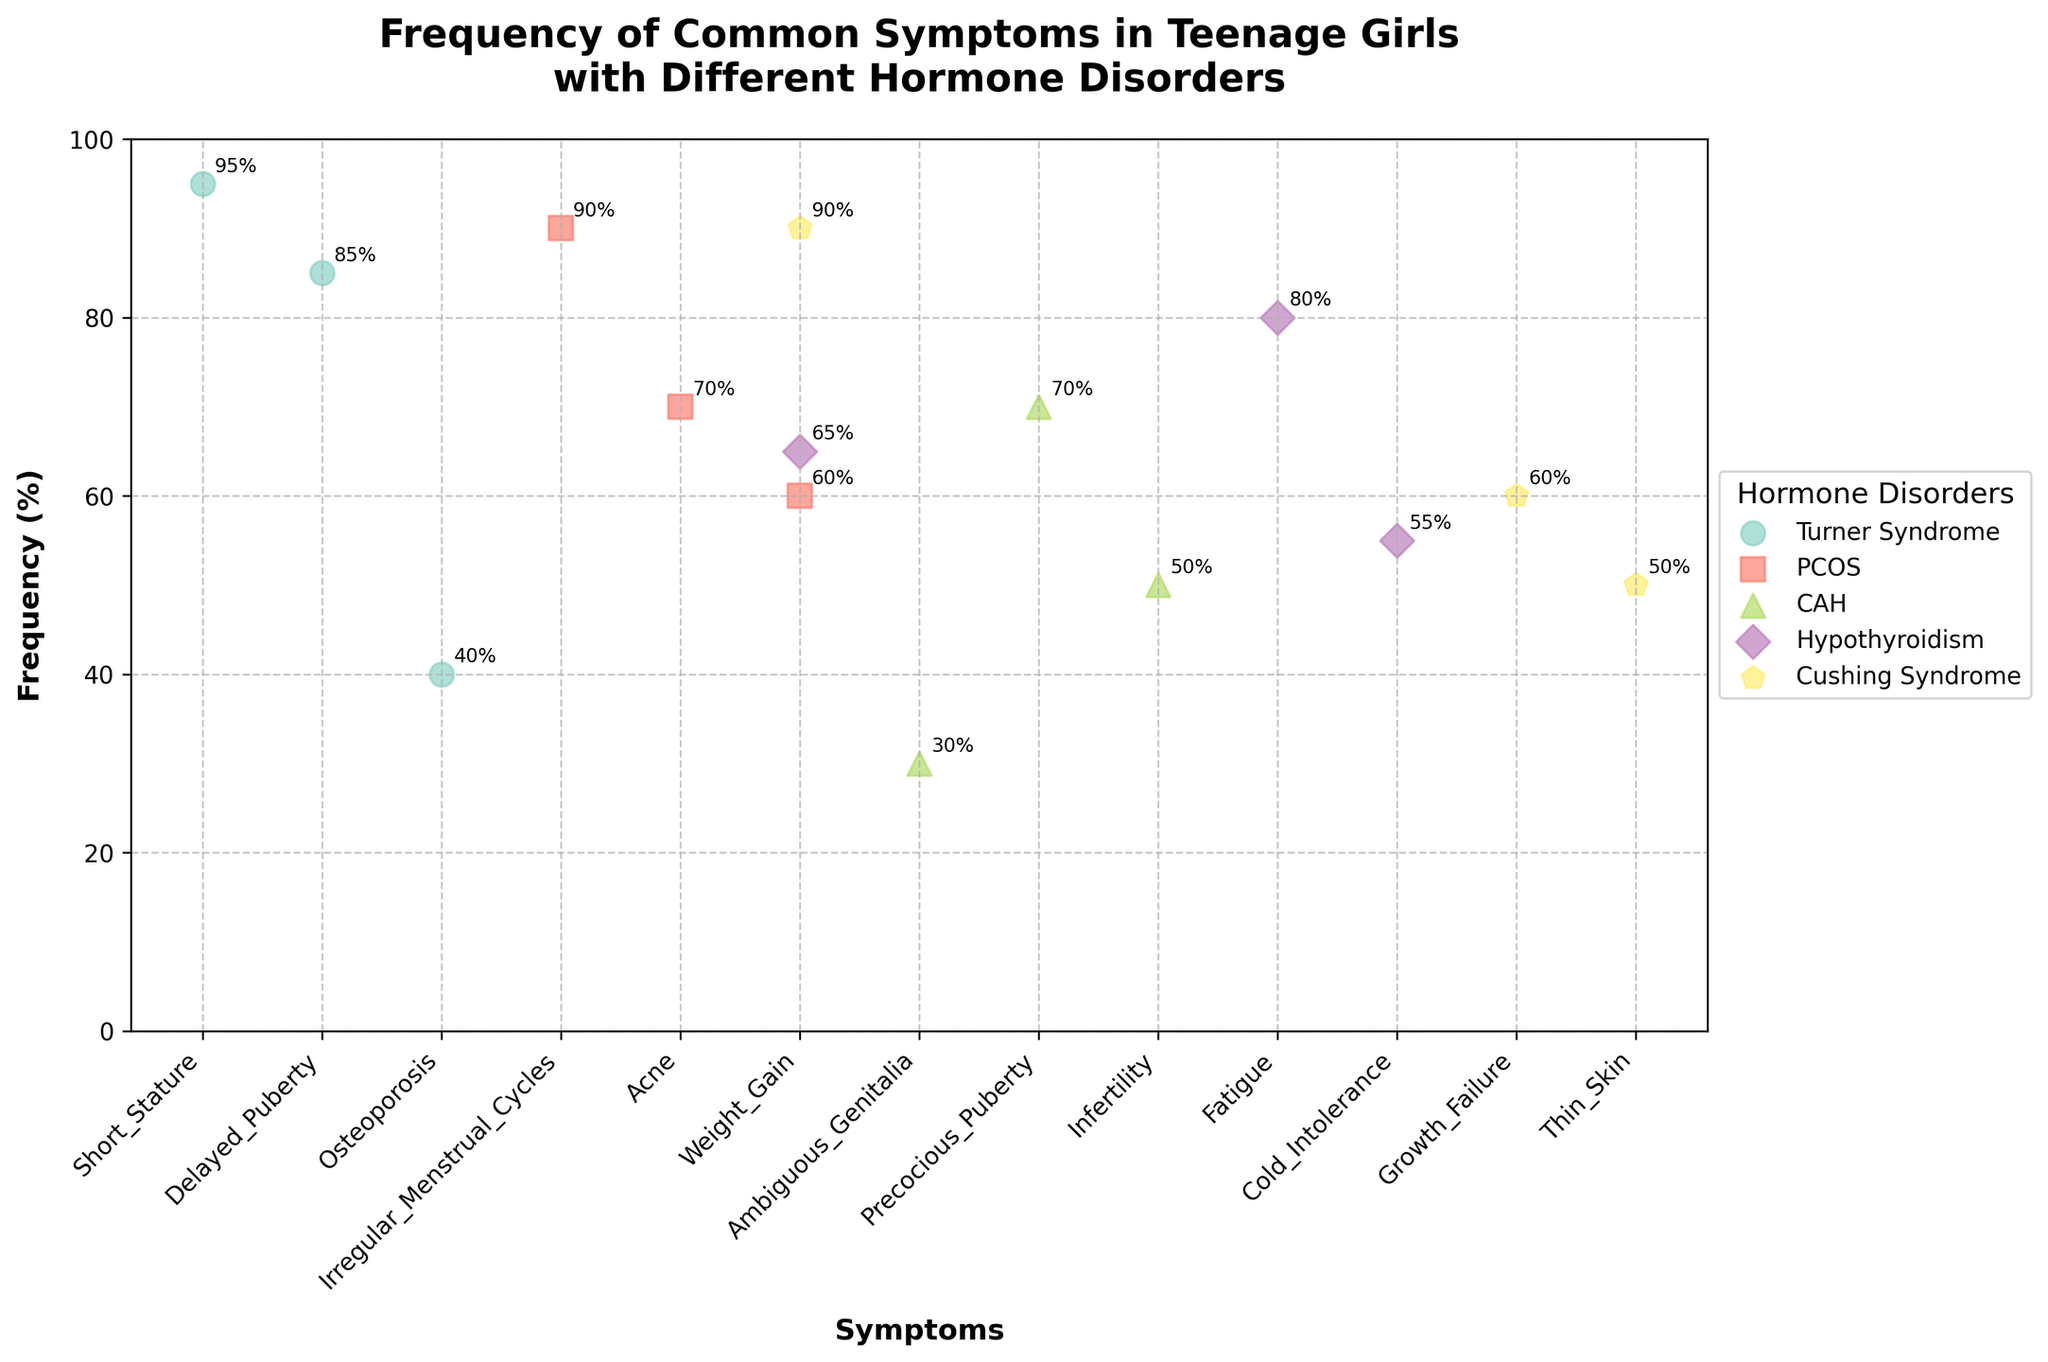Which hormone disorder has the highest frequency for weight gain? To determine which hormone disorder has the highest frequency for weight gain, look at the data points corresponding to the "Weight Gain" symptom and compare their frequencies. The highest frequency for weight gain is listed under PCOS and Cushing Syndrome, both at 90%.
Answer: PCOS and Cushing Syndrome What is the average frequency of symptoms for Turner Syndrome? Calculate the average frequency of the listed symptoms for Turner Syndrome (95, 85, 40). Add their frequencies: 95 + 85 + 40 = 220. Then, divide by the number of symptoms: 220 / 3 ≈ 73.33.
Answer: 73.33% Which symptom has the highest frequency across all hormone disorders? To find the symptom with the highest frequency, identify the data points with the highest frequency percentage across all disorders. Short Stature under Turner Syndrome has a frequency of 95%, which is the highest.
Answer: Short Stature (Turner Syndrome) Between PCOS and Hypothyroidism, which disorder has a higher average symptom frequency? To compare the average frequencies, first calculate the average frequency for PCOS: (90 + 70 + 60) / 3 = 73.33%. Next, calculate the average frequency for Hypothyroidism: (80 + 65 + 55) / 3 ≈ 66.67%. PCOS has a higher average frequency.
Answer: PCOS How does the frequency of irregular menstrual cycles in girls with PCOS compare to the frequency of fatigue in girls with hypothyroidism? Compare the individual frequencies of these symptoms: irregular menstrual cycles (PCOS) is 90% and fatigue (Hypothyroidism) is 80%. Irregular menstrual cycles in girls with PCOS is higher by 10 percentage points.
Answer: Irregular Menstrual Cycles (PCOS) Which hormone disorder has the most varied symptom frequencies? To determine the most varied symptom frequencies, look for the disorder with symptoms that have a wide range of frequencies. Turner Syndrome has frequencies of 95%, 85%, and 40%, making its range 55%. This is more varied than the other disorders.
Answer: Turner Syndrome Are there any disorders with a symptom frequency lower than 50%? Identify symptoms with a frequency lower than 50% in the scatter plot. Turner Syndrome (Osteoporosis, 40%) and CAH (Ambiguous Genitalia, 30%) are below 50%.
Answer: Yes Which disorder has the lowest frequency symptom overall, and what is that symptom? Locate the data point with the smallest frequency percentage. The lowest frequency overall is 30%, which corresponds to Ambiguous Genitalia in CAH.
Answer: CAH, Ambiguous Genitalia What percentage of symptoms for Cushing Syndrome has a frequency of 50% or more? First, list the frequencies of Cushing Syndrome symptoms (90%, 60%, 50%). All three symptoms meet the 50% or more criteria. Since there are three symptoms, the percentage is (3/3)*100%.
Answer: 100% For CAH, which symptom has the highest frequency, and what is it? Identify the symptom with the highest frequency under CAH. The highest frequency symptom for CAH is Precocious Puberty with a frequency of 70%.
Answer: Precocious Puberty (70%) 